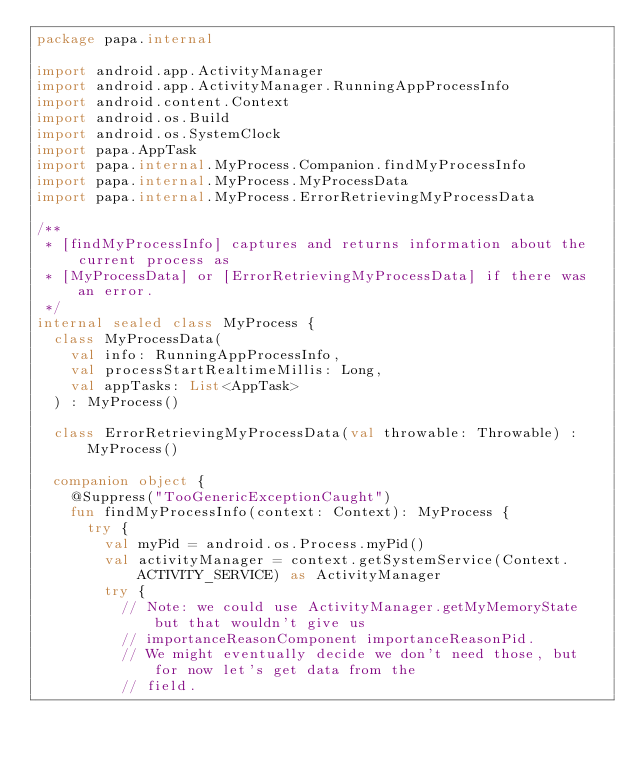<code> <loc_0><loc_0><loc_500><loc_500><_Kotlin_>package papa.internal

import android.app.ActivityManager
import android.app.ActivityManager.RunningAppProcessInfo
import android.content.Context
import android.os.Build
import android.os.SystemClock
import papa.AppTask
import papa.internal.MyProcess.Companion.findMyProcessInfo
import papa.internal.MyProcess.MyProcessData
import papa.internal.MyProcess.ErrorRetrievingMyProcessData

/**
 * [findMyProcessInfo] captures and returns information about the current process as
 * [MyProcessData] or [ErrorRetrievingMyProcessData] if there was an error.
 */
internal sealed class MyProcess {
  class MyProcessData(
    val info: RunningAppProcessInfo,
    val processStartRealtimeMillis: Long,
    val appTasks: List<AppTask>
  ) : MyProcess()

  class ErrorRetrievingMyProcessData(val throwable: Throwable) : MyProcess()

  companion object {
    @Suppress("TooGenericExceptionCaught")
    fun findMyProcessInfo(context: Context): MyProcess {
      try {
        val myPid = android.os.Process.myPid()
        val activityManager = context.getSystemService(Context.ACTIVITY_SERVICE) as ActivityManager
        try {
          // Note: we could use ActivityManager.getMyMemoryState but that wouldn't give us
          // importanceReasonComponent importanceReasonPid.
          // We might eventually decide we don't need those, but for now let's get data from the
          // field.</code> 